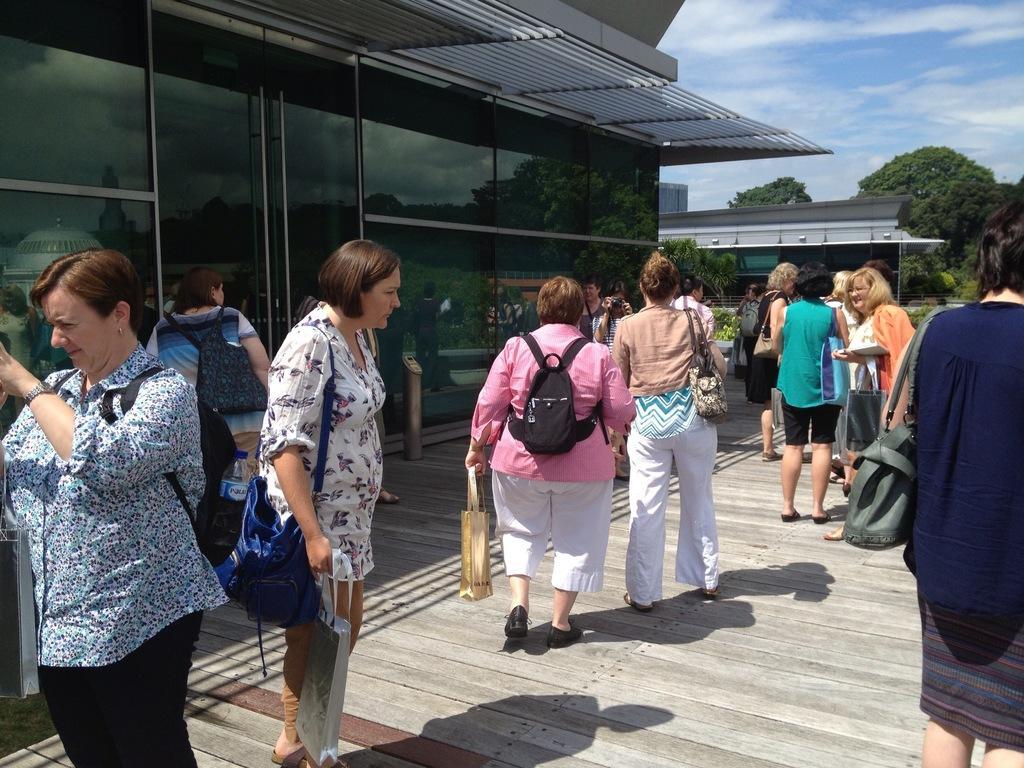How would you summarize this image in a sentence or two? On the left side of the image we can see a lady wore a blue and black color dress and she wore a backpack and standing there. In the middle of the image we can see some person are walking and everyone is carrying bags in their hands. On the right side of the image we can see some persons and two people are talking to each other. Here we can see some trees and the sky. 